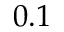Convert formula to latex. <formula><loc_0><loc_0><loc_500><loc_500>0 . 1</formula> 